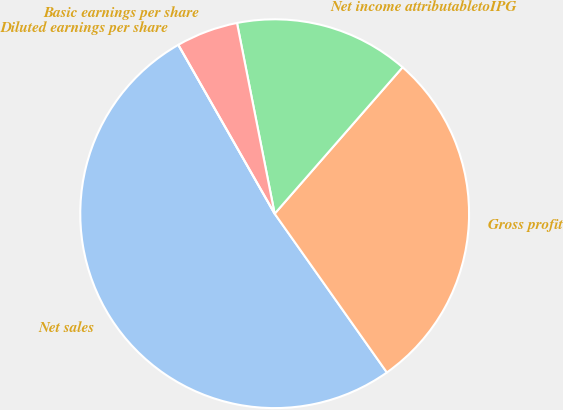Convert chart. <chart><loc_0><loc_0><loc_500><loc_500><pie_chart><fcel>Net sales<fcel>Gross profit<fcel>Net income attributabletoIPG<fcel>Basic earnings per share<fcel>Diluted earnings per share<nl><fcel>51.54%<fcel>28.78%<fcel>14.53%<fcel>5.15%<fcel>0.0%<nl></chart> 